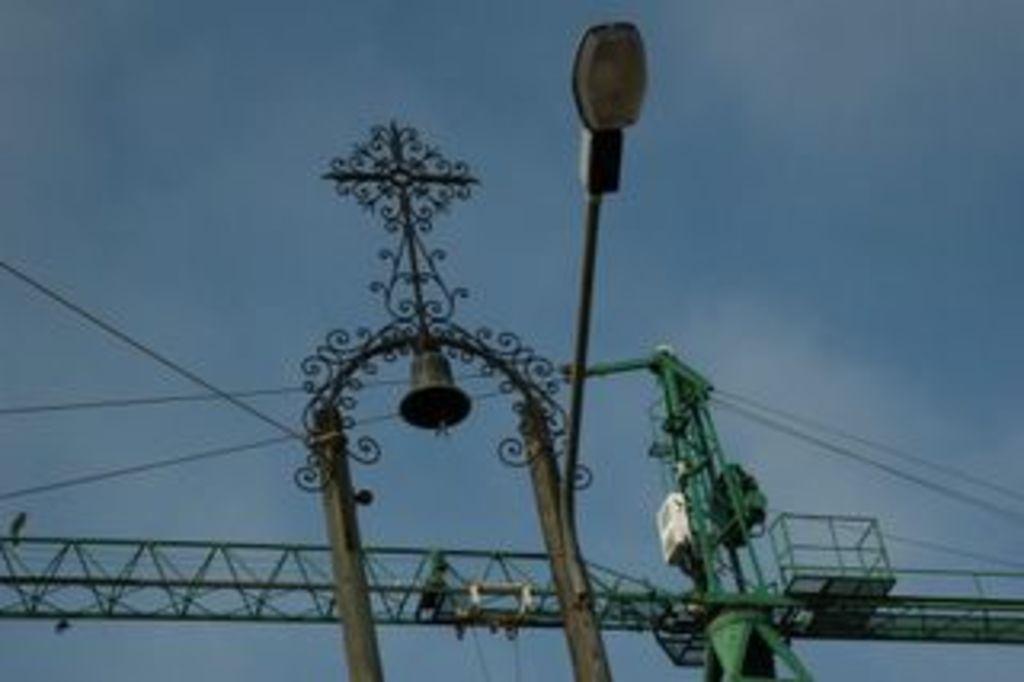Describe this image in one or two sentences. In this image there is a lamp post, bell, metal rods, cables and a crane. 